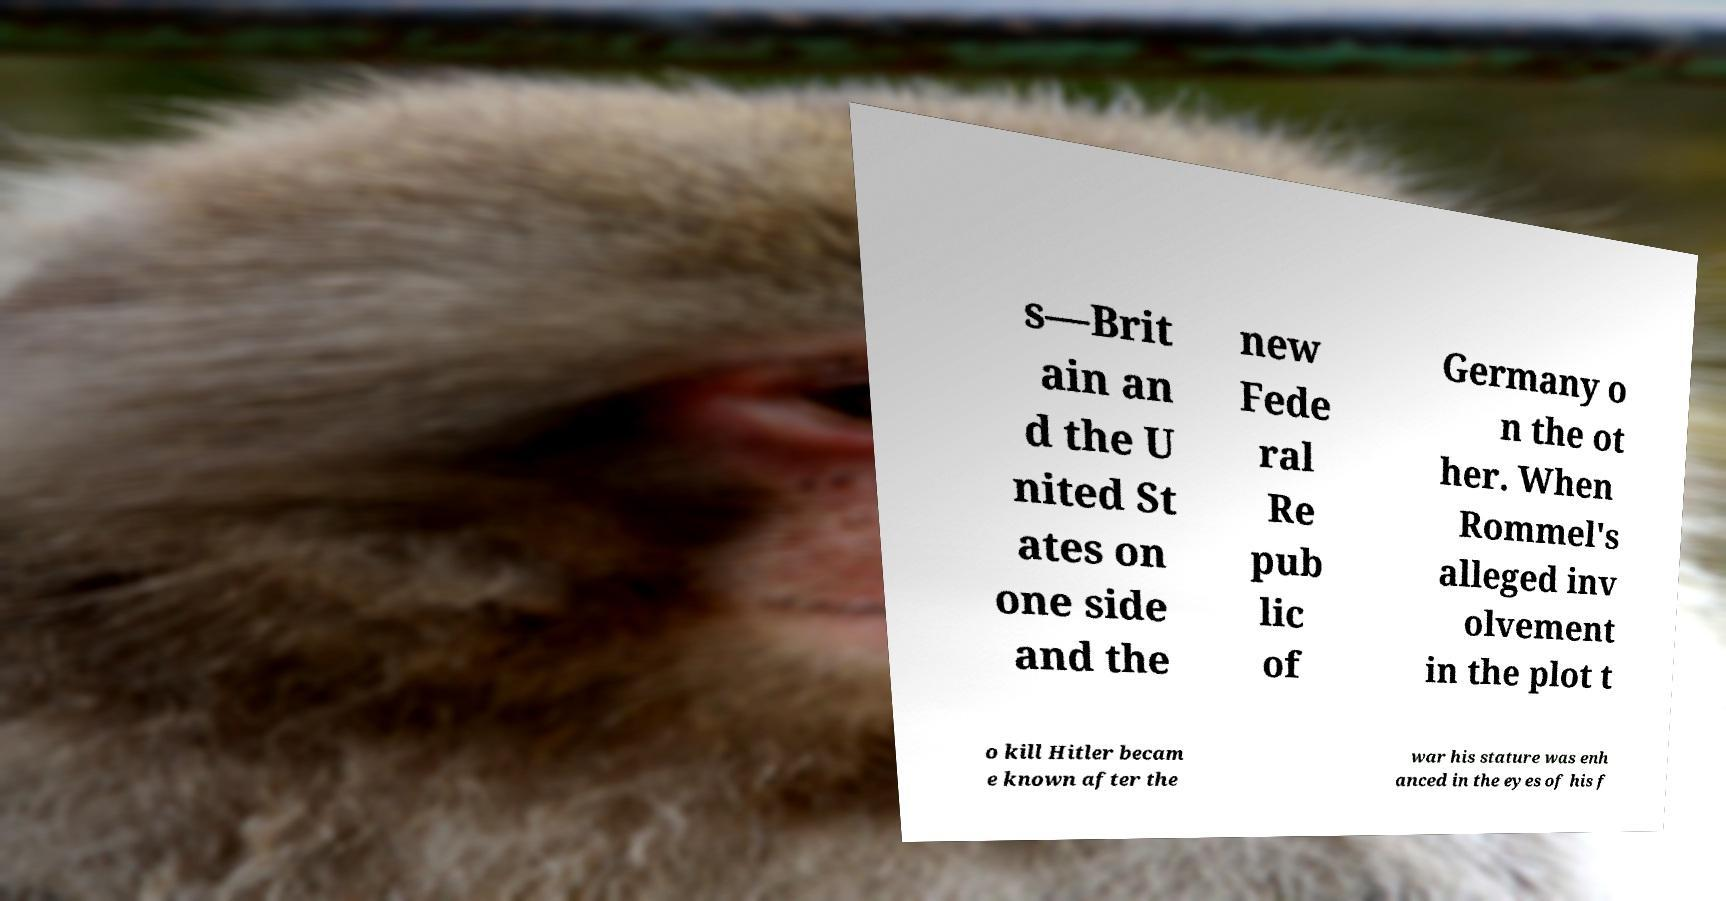Please read and relay the text visible in this image. What does it say? s—Brit ain an d the U nited St ates on one side and the new Fede ral Re pub lic of Germany o n the ot her. When Rommel's alleged inv olvement in the plot t o kill Hitler becam e known after the war his stature was enh anced in the eyes of his f 